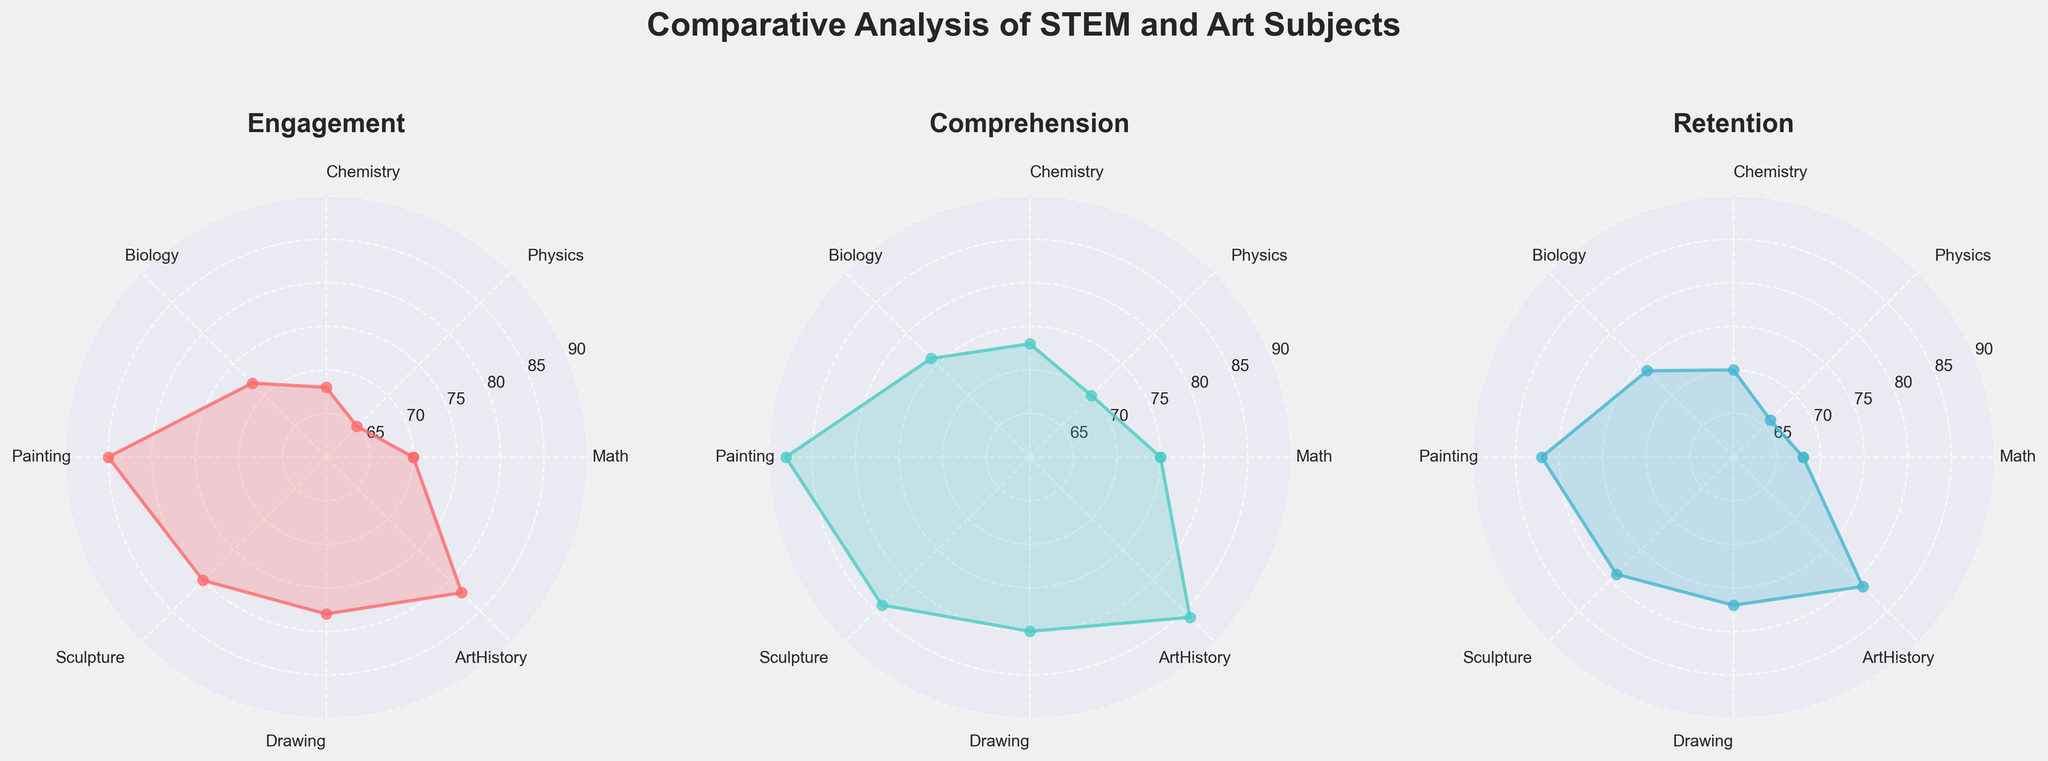How many categories are compared in the radar charts? There are several categories (Math, Physics, Chemistry, Biology, Painting, Sculpture, Drawing, ArtHistory) represented in the radar charts. By counting them, we get a total of eight categories.
Answer: Eight What is the title of the leftmost radar chart? The title of the leftmost radar chart is mentioned directly above it, which is 'Engagement'.
Answer: Engagement Which subject has the highest level of Engagement? To find the highest level of Engagement, we look for the maximum value in the Engagement radar chart. Painting shows an engagement level of 85, which is the highest among all subjects.
Answer: Painting Between Math and Drawing, which subject has better Retention? By comparing the Retention values for Math and Drawing in the Retention radar chart, Math has a value of 68, whereas Drawing has a value of 77. Because 77 is greater than 68, Drawing has better Retention.
Answer: Drawing What is the average Comprehension level for STEM subjects represented? To find the average Comprehension level for STEM subjects, sum the Comprehension values for Math, Physics, Chemistry, and Biology and divide by 4. (75 + 70 + 73 + 76) / 4 = 73.5.
Answer: 73.5 Which subject shows the lowest Comprehension among the Art subjects? To find the lowest Comprehension, compare the values for Painting, Sculpture, Drawing, and Art History in the Comprehension radar chart. Physics stands at 70, which is the lowest.
Answer: Sculpture What is the difference in Engagement levels between Biology and Sculpture? Calculate the difference in Engagement levels by subtracting Sculpture's Engagement (80) from Biology's Engagement (72). 72 - 80 = -8.
Answer: -8 What is the common trend observed in all three radar charts for Painting? By examining all three radar charts, we notice that Painting consistently holds the highest or among the highest values in Engagement (85), Comprehension (88), and Retention (82).
Answer: High values Is there any category where Retention is higher than both Engagement and Comprehension? By analyzing each category, we note that in all cases either Engagement or Comprehension is higher than Retention. None of the subjects have Retention values higher than both Engagement and Comprehension.
Answer: No 